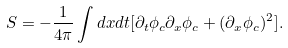<formula> <loc_0><loc_0><loc_500><loc_500>S = - \frac { 1 } { 4 \pi } \int d x d t [ \partial _ { t } \phi _ { c } \partial _ { x } \phi _ { c } + ( { \partial _ { x } \phi _ { c } } ) ^ { 2 } ] .</formula> 